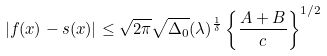Convert formula to latex. <formula><loc_0><loc_0><loc_500><loc_500>| f ( x ) - s ( x ) | \leq \sqrt { 2 \pi } \sqrt { \Delta _ { 0 } } ( \lambda ) ^ { \frac { 1 } { \delta } } \left \{ \frac { A + B } { c } \right \} ^ { 1 / 2 }</formula> 